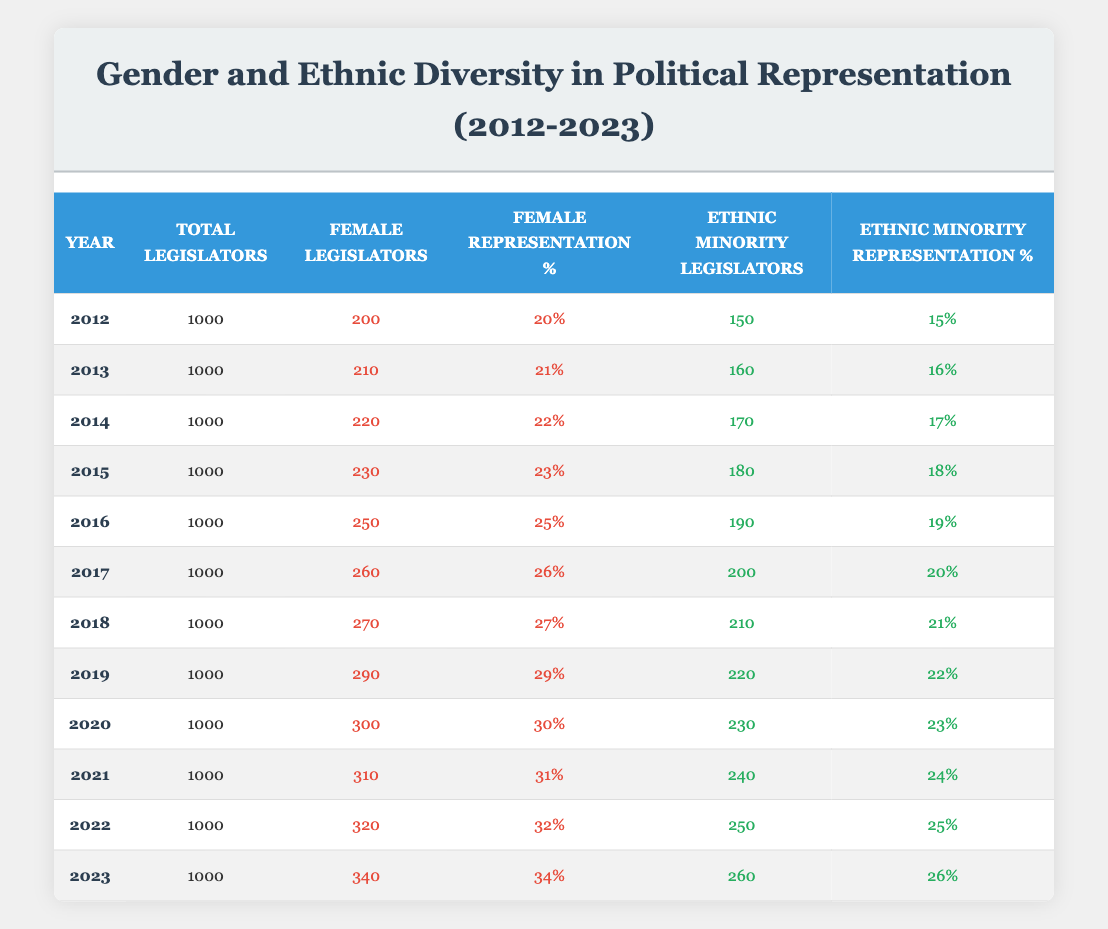What was the percentage of female legislators in 2015? In 2015, the female representation percentage is directly listed in the table under the corresponding year. Referring to the 2015 row, the value is 23%.
Answer: 23% How many ethnic minority legislators were there in 2021? The table provides the number of ethnic minority legislators for each year, specifically listing 240 in the year 2021.
Answer: 240 What is the total increase in the number of female legislators from 2012 to 2023? The number of female legislators in 2012 is 200, and in 2023 it is 340. To find the increase, subtract the earlier number from the later number: 340 - 200 = 140.
Answer: 140 Was the percentage of ethnic minority representation higher or lower in 2016 compared to 2019? By examining the table, the ethnic minority representation percentage in 2016 is 19% and in 2019 it is 22%. Since 22% is greater than 19%, the representation was higher in 2019.
Answer: Higher What was the average percentage of female legislators from 2012 to 2022? To find the average, first sum the female representation percentages over the specified years: 20 + 21 + 22 + 23 + 25 + 26 + 27 + 29 + 30 + 31 + 32 =  25. The average is then 25/11 = 25%.
Answer: 25% How many more ethnic minority legislators were there in 2023 compared to 2018? From the table, the number of ethnic minority legislators in 2023 is 260, while in 2018 it is 210. To find the difference, calculate: 260 - 210 = 50.
Answer: 50 Did female representation increase every year from 2012 to 2023? Examining the female representation percentages for each year in the table, it shows a consistent year-over-year increase from 20% in 2012 to 34% in 2023, confirming that it did.
Answer: Yes What is the total count of legislators of both genders in 2019? Since the total number of legislators for all years is consistent at 1000, thus for 2019, the total count remains 1000.
Answer: 1000 How does the percentage of ethnic minority legislators in 2020 compare to the average percentage from 2012 to 2020? The percentage of ethnic minority legislators in 2020 is 23%. To find the average from 2012 to 2020, calculate the sum of the percentages: 15 + 16 + 17 + 18 + 19 + 20 + 21 + 22 + 23 = 171, and then divide by 9, resulting in an average of 19%. Since 23% is greater than 19%, the 2020 percentage is higher.
Answer: Higher 